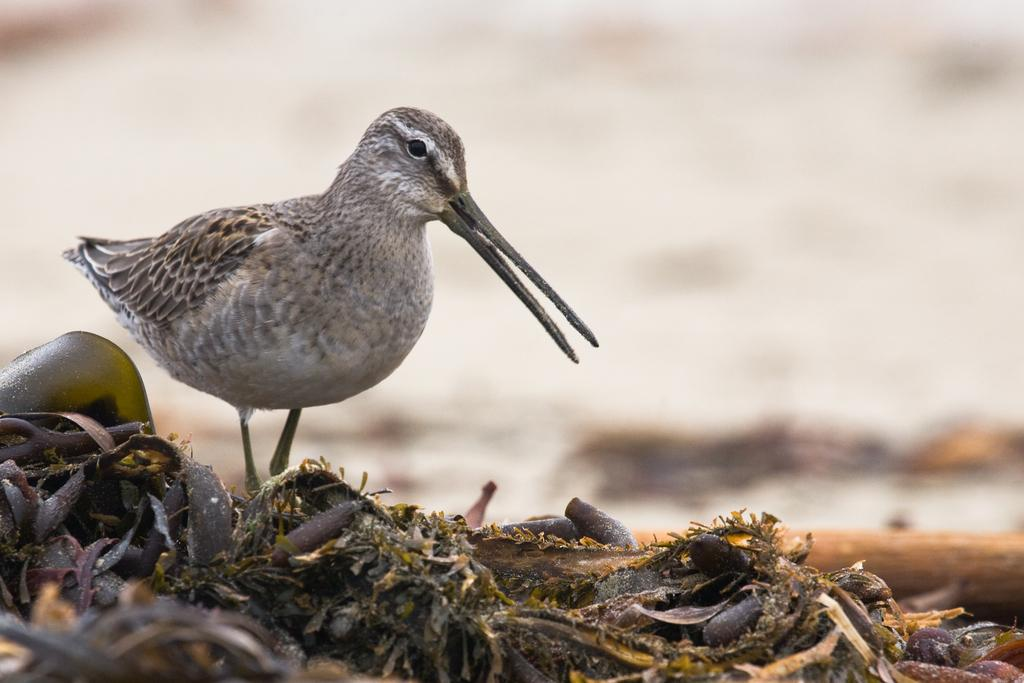What type of animal can be seen in the image? There is a bird in the image. What is the bird standing on? The bird is standing on dry leaves. What can be observed in the image that might indicate the environment? Dust is present in the image. What type of loaf is the bird holding in the image? There is no loaf present in the image; the bird is standing on dry leaves. What hope does the bird have for finding food in the image? The image does not provide any information about the bird's hope for finding food. 